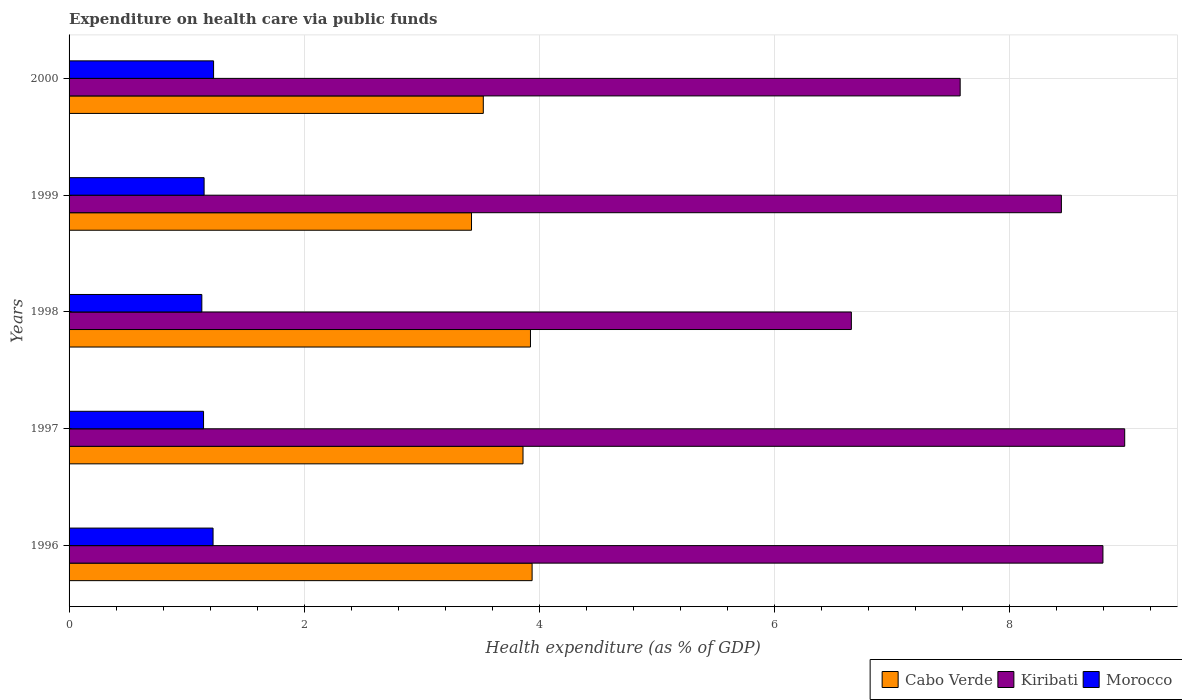How many different coloured bars are there?
Offer a very short reply. 3. Are the number of bars on each tick of the Y-axis equal?
Provide a short and direct response. Yes. How many bars are there on the 5th tick from the top?
Ensure brevity in your answer.  3. In how many cases, is the number of bars for a given year not equal to the number of legend labels?
Your answer should be very brief. 0. What is the expenditure made on health care in Kiribati in 1996?
Give a very brief answer. 8.8. Across all years, what is the maximum expenditure made on health care in Kiribati?
Your answer should be compact. 8.98. Across all years, what is the minimum expenditure made on health care in Morocco?
Provide a short and direct response. 1.13. In which year was the expenditure made on health care in Kiribati maximum?
Your answer should be very brief. 1997. What is the total expenditure made on health care in Morocco in the graph?
Ensure brevity in your answer.  5.88. What is the difference between the expenditure made on health care in Cabo Verde in 1998 and that in 2000?
Make the answer very short. 0.4. What is the difference between the expenditure made on health care in Cabo Verde in 1996 and the expenditure made on health care in Kiribati in 1998?
Offer a terse response. -2.72. What is the average expenditure made on health care in Cabo Verde per year?
Provide a short and direct response. 3.74. In the year 1996, what is the difference between the expenditure made on health care in Kiribati and expenditure made on health care in Morocco?
Make the answer very short. 7.57. In how many years, is the expenditure made on health care in Cabo Verde greater than 7.2 %?
Keep it short and to the point. 0. What is the ratio of the expenditure made on health care in Morocco in 1997 to that in 1998?
Give a very brief answer. 1.01. Is the expenditure made on health care in Cabo Verde in 1996 less than that in 2000?
Provide a succinct answer. No. Is the difference between the expenditure made on health care in Kiribati in 1996 and 2000 greater than the difference between the expenditure made on health care in Morocco in 1996 and 2000?
Your answer should be very brief. Yes. What is the difference between the highest and the second highest expenditure made on health care in Morocco?
Ensure brevity in your answer.  0. What is the difference between the highest and the lowest expenditure made on health care in Kiribati?
Provide a succinct answer. 2.33. In how many years, is the expenditure made on health care in Morocco greater than the average expenditure made on health care in Morocco taken over all years?
Ensure brevity in your answer.  2. What does the 2nd bar from the top in 2000 represents?
Offer a very short reply. Kiribati. What does the 3rd bar from the bottom in 2000 represents?
Keep it short and to the point. Morocco. Is it the case that in every year, the sum of the expenditure made on health care in Kiribati and expenditure made on health care in Morocco is greater than the expenditure made on health care in Cabo Verde?
Your answer should be very brief. Yes. How many years are there in the graph?
Make the answer very short. 5. What is the difference between two consecutive major ticks on the X-axis?
Your answer should be very brief. 2. Does the graph contain grids?
Your response must be concise. Yes. How many legend labels are there?
Make the answer very short. 3. What is the title of the graph?
Give a very brief answer. Expenditure on health care via public funds. Does "Palau" appear as one of the legend labels in the graph?
Keep it short and to the point. No. What is the label or title of the X-axis?
Your answer should be compact. Health expenditure (as % of GDP). What is the Health expenditure (as % of GDP) of Cabo Verde in 1996?
Your answer should be very brief. 3.94. What is the Health expenditure (as % of GDP) in Kiribati in 1996?
Offer a terse response. 8.8. What is the Health expenditure (as % of GDP) of Morocco in 1996?
Provide a succinct answer. 1.23. What is the Health expenditure (as % of GDP) of Cabo Verde in 1997?
Your answer should be very brief. 3.86. What is the Health expenditure (as % of GDP) in Kiribati in 1997?
Make the answer very short. 8.98. What is the Health expenditure (as % of GDP) of Morocco in 1997?
Provide a short and direct response. 1.14. What is the Health expenditure (as % of GDP) of Cabo Verde in 1998?
Your answer should be very brief. 3.93. What is the Health expenditure (as % of GDP) of Kiribati in 1998?
Ensure brevity in your answer.  6.66. What is the Health expenditure (as % of GDP) of Morocco in 1998?
Make the answer very short. 1.13. What is the Health expenditure (as % of GDP) in Cabo Verde in 1999?
Offer a terse response. 3.42. What is the Health expenditure (as % of GDP) in Kiribati in 1999?
Ensure brevity in your answer.  8.44. What is the Health expenditure (as % of GDP) in Morocco in 1999?
Ensure brevity in your answer.  1.15. What is the Health expenditure (as % of GDP) of Cabo Verde in 2000?
Keep it short and to the point. 3.52. What is the Health expenditure (as % of GDP) in Kiribati in 2000?
Your answer should be compact. 7.58. What is the Health expenditure (as % of GDP) in Morocco in 2000?
Offer a very short reply. 1.23. Across all years, what is the maximum Health expenditure (as % of GDP) of Cabo Verde?
Provide a short and direct response. 3.94. Across all years, what is the maximum Health expenditure (as % of GDP) in Kiribati?
Provide a succinct answer. 8.98. Across all years, what is the maximum Health expenditure (as % of GDP) of Morocco?
Provide a succinct answer. 1.23. Across all years, what is the minimum Health expenditure (as % of GDP) in Cabo Verde?
Offer a very short reply. 3.42. Across all years, what is the minimum Health expenditure (as % of GDP) of Kiribati?
Your answer should be compact. 6.66. Across all years, what is the minimum Health expenditure (as % of GDP) of Morocco?
Provide a succinct answer. 1.13. What is the total Health expenditure (as % of GDP) of Cabo Verde in the graph?
Provide a short and direct response. 18.68. What is the total Health expenditure (as % of GDP) in Kiribati in the graph?
Ensure brevity in your answer.  40.46. What is the total Health expenditure (as % of GDP) of Morocco in the graph?
Your answer should be very brief. 5.88. What is the difference between the Health expenditure (as % of GDP) of Cabo Verde in 1996 and that in 1997?
Your answer should be very brief. 0.08. What is the difference between the Health expenditure (as % of GDP) of Kiribati in 1996 and that in 1997?
Provide a short and direct response. -0.19. What is the difference between the Health expenditure (as % of GDP) of Morocco in 1996 and that in 1997?
Your answer should be very brief. 0.08. What is the difference between the Health expenditure (as % of GDP) in Cabo Verde in 1996 and that in 1998?
Keep it short and to the point. 0.01. What is the difference between the Health expenditure (as % of GDP) of Kiribati in 1996 and that in 1998?
Provide a succinct answer. 2.14. What is the difference between the Health expenditure (as % of GDP) of Morocco in 1996 and that in 1998?
Ensure brevity in your answer.  0.1. What is the difference between the Health expenditure (as % of GDP) of Cabo Verde in 1996 and that in 1999?
Provide a succinct answer. 0.52. What is the difference between the Health expenditure (as % of GDP) in Kiribati in 1996 and that in 1999?
Give a very brief answer. 0.35. What is the difference between the Health expenditure (as % of GDP) in Morocco in 1996 and that in 1999?
Make the answer very short. 0.08. What is the difference between the Health expenditure (as % of GDP) in Cabo Verde in 1996 and that in 2000?
Provide a short and direct response. 0.42. What is the difference between the Health expenditure (as % of GDP) in Kiribati in 1996 and that in 2000?
Give a very brief answer. 1.21. What is the difference between the Health expenditure (as % of GDP) in Morocco in 1996 and that in 2000?
Keep it short and to the point. -0. What is the difference between the Health expenditure (as % of GDP) of Cabo Verde in 1997 and that in 1998?
Provide a short and direct response. -0.06. What is the difference between the Health expenditure (as % of GDP) of Kiribati in 1997 and that in 1998?
Keep it short and to the point. 2.33. What is the difference between the Health expenditure (as % of GDP) of Morocco in 1997 and that in 1998?
Offer a very short reply. 0.01. What is the difference between the Health expenditure (as % of GDP) in Cabo Verde in 1997 and that in 1999?
Provide a succinct answer. 0.44. What is the difference between the Health expenditure (as % of GDP) of Kiribati in 1997 and that in 1999?
Ensure brevity in your answer.  0.54. What is the difference between the Health expenditure (as % of GDP) in Morocco in 1997 and that in 1999?
Provide a succinct answer. -0. What is the difference between the Health expenditure (as % of GDP) in Cabo Verde in 1997 and that in 2000?
Your response must be concise. 0.34. What is the difference between the Health expenditure (as % of GDP) in Kiribati in 1997 and that in 2000?
Give a very brief answer. 1.4. What is the difference between the Health expenditure (as % of GDP) in Morocco in 1997 and that in 2000?
Ensure brevity in your answer.  -0.09. What is the difference between the Health expenditure (as % of GDP) of Cabo Verde in 1998 and that in 1999?
Offer a very short reply. 0.5. What is the difference between the Health expenditure (as % of GDP) of Kiribati in 1998 and that in 1999?
Keep it short and to the point. -1.79. What is the difference between the Health expenditure (as % of GDP) in Morocco in 1998 and that in 1999?
Make the answer very short. -0.02. What is the difference between the Health expenditure (as % of GDP) in Cabo Verde in 1998 and that in 2000?
Ensure brevity in your answer.  0.4. What is the difference between the Health expenditure (as % of GDP) in Kiribati in 1998 and that in 2000?
Keep it short and to the point. -0.93. What is the difference between the Health expenditure (as % of GDP) in Morocco in 1998 and that in 2000?
Offer a very short reply. -0.1. What is the difference between the Health expenditure (as % of GDP) of Cabo Verde in 1999 and that in 2000?
Keep it short and to the point. -0.1. What is the difference between the Health expenditure (as % of GDP) of Kiribati in 1999 and that in 2000?
Your answer should be very brief. 0.86. What is the difference between the Health expenditure (as % of GDP) in Morocco in 1999 and that in 2000?
Ensure brevity in your answer.  -0.08. What is the difference between the Health expenditure (as % of GDP) of Cabo Verde in 1996 and the Health expenditure (as % of GDP) of Kiribati in 1997?
Offer a very short reply. -5.04. What is the difference between the Health expenditure (as % of GDP) in Cabo Verde in 1996 and the Health expenditure (as % of GDP) in Morocco in 1997?
Make the answer very short. 2.8. What is the difference between the Health expenditure (as % of GDP) of Kiribati in 1996 and the Health expenditure (as % of GDP) of Morocco in 1997?
Provide a succinct answer. 7.65. What is the difference between the Health expenditure (as % of GDP) in Cabo Verde in 1996 and the Health expenditure (as % of GDP) in Kiribati in 1998?
Your response must be concise. -2.72. What is the difference between the Health expenditure (as % of GDP) of Cabo Verde in 1996 and the Health expenditure (as % of GDP) of Morocco in 1998?
Provide a succinct answer. 2.81. What is the difference between the Health expenditure (as % of GDP) of Kiribati in 1996 and the Health expenditure (as % of GDP) of Morocco in 1998?
Provide a succinct answer. 7.67. What is the difference between the Health expenditure (as % of GDP) in Cabo Verde in 1996 and the Health expenditure (as % of GDP) in Kiribati in 1999?
Your answer should be compact. -4.5. What is the difference between the Health expenditure (as % of GDP) in Cabo Verde in 1996 and the Health expenditure (as % of GDP) in Morocco in 1999?
Offer a terse response. 2.79. What is the difference between the Health expenditure (as % of GDP) of Kiribati in 1996 and the Health expenditure (as % of GDP) of Morocco in 1999?
Your answer should be compact. 7.65. What is the difference between the Health expenditure (as % of GDP) in Cabo Verde in 1996 and the Health expenditure (as % of GDP) in Kiribati in 2000?
Offer a very short reply. -3.64. What is the difference between the Health expenditure (as % of GDP) in Cabo Verde in 1996 and the Health expenditure (as % of GDP) in Morocco in 2000?
Offer a very short reply. 2.71. What is the difference between the Health expenditure (as % of GDP) in Kiribati in 1996 and the Health expenditure (as % of GDP) in Morocco in 2000?
Ensure brevity in your answer.  7.57. What is the difference between the Health expenditure (as % of GDP) of Cabo Verde in 1997 and the Health expenditure (as % of GDP) of Kiribati in 1998?
Provide a succinct answer. -2.79. What is the difference between the Health expenditure (as % of GDP) of Cabo Verde in 1997 and the Health expenditure (as % of GDP) of Morocco in 1998?
Offer a terse response. 2.73. What is the difference between the Health expenditure (as % of GDP) of Kiribati in 1997 and the Health expenditure (as % of GDP) of Morocco in 1998?
Keep it short and to the point. 7.85. What is the difference between the Health expenditure (as % of GDP) of Cabo Verde in 1997 and the Health expenditure (as % of GDP) of Kiribati in 1999?
Make the answer very short. -4.58. What is the difference between the Health expenditure (as % of GDP) of Cabo Verde in 1997 and the Health expenditure (as % of GDP) of Morocco in 1999?
Make the answer very short. 2.71. What is the difference between the Health expenditure (as % of GDP) of Kiribati in 1997 and the Health expenditure (as % of GDP) of Morocco in 1999?
Provide a short and direct response. 7.83. What is the difference between the Health expenditure (as % of GDP) of Cabo Verde in 1997 and the Health expenditure (as % of GDP) of Kiribati in 2000?
Your response must be concise. -3.72. What is the difference between the Health expenditure (as % of GDP) of Cabo Verde in 1997 and the Health expenditure (as % of GDP) of Morocco in 2000?
Your response must be concise. 2.63. What is the difference between the Health expenditure (as % of GDP) in Kiribati in 1997 and the Health expenditure (as % of GDP) in Morocco in 2000?
Keep it short and to the point. 7.75. What is the difference between the Health expenditure (as % of GDP) of Cabo Verde in 1998 and the Health expenditure (as % of GDP) of Kiribati in 1999?
Make the answer very short. -4.52. What is the difference between the Health expenditure (as % of GDP) in Cabo Verde in 1998 and the Health expenditure (as % of GDP) in Morocco in 1999?
Your answer should be very brief. 2.78. What is the difference between the Health expenditure (as % of GDP) in Kiribati in 1998 and the Health expenditure (as % of GDP) in Morocco in 1999?
Ensure brevity in your answer.  5.51. What is the difference between the Health expenditure (as % of GDP) of Cabo Verde in 1998 and the Health expenditure (as % of GDP) of Kiribati in 2000?
Provide a succinct answer. -3.66. What is the difference between the Health expenditure (as % of GDP) in Cabo Verde in 1998 and the Health expenditure (as % of GDP) in Morocco in 2000?
Offer a terse response. 2.7. What is the difference between the Health expenditure (as % of GDP) of Kiribati in 1998 and the Health expenditure (as % of GDP) of Morocco in 2000?
Your response must be concise. 5.43. What is the difference between the Health expenditure (as % of GDP) in Cabo Verde in 1999 and the Health expenditure (as % of GDP) in Kiribati in 2000?
Ensure brevity in your answer.  -4.16. What is the difference between the Health expenditure (as % of GDP) in Cabo Verde in 1999 and the Health expenditure (as % of GDP) in Morocco in 2000?
Ensure brevity in your answer.  2.19. What is the difference between the Health expenditure (as % of GDP) in Kiribati in 1999 and the Health expenditure (as % of GDP) in Morocco in 2000?
Your answer should be very brief. 7.21. What is the average Health expenditure (as % of GDP) in Cabo Verde per year?
Give a very brief answer. 3.74. What is the average Health expenditure (as % of GDP) in Kiribati per year?
Keep it short and to the point. 8.09. What is the average Health expenditure (as % of GDP) in Morocco per year?
Keep it short and to the point. 1.18. In the year 1996, what is the difference between the Health expenditure (as % of GDP) of Cabo Verde and Health expenditure (as % of GDP) of Kiribati?
Your answer should be compact. -4.86. In the year 1996, what is the difference between the Health expenditure (as % of GDP) in Cabo Verde and Health expenditure (as % of GDP) in Morocco?
Make the answer very short. 2.71. In the year 1996, what is the difference between the Health expenditure (as % of GDP) in Kiribati and Health expenditure (as % of GDP) in Morocco?
Your answer should be very brief. 7.57. In the year 1997, what is the difference between the Health expenditure (as % of GDP) of Cabo Verde and Health expenditure (as % of GDP) of Kiribati?
Offer a terse response. -5.12. In the year 1997, what is the difference between the Health expenditure (as % of GDP) of Cabo Verde and Health expenditure (as % of GDP) of Morocco?
Give a very brief answer. 2.72. In the year 1997, what is the difference between the Health expenditure (as % of GDP) of Kiribati and Health expenditure (as % of GDP) of Morocco?
Keep it short and to the point. 7.84. In the year 1998, what is the difference between the Health expenditure (as % of GDP) in Cabo Verde and Health expenditure (as % of GDP) in Kiribati?
Provide a succinct answer. -2.73. In the year 1998, what is the difference between the Health expenditure (as % of GDP) in Cabo Verde and Health expenditure (as % of GDP) in Morocco?
Your answer should be very brief. 2.8. In the year 1998, what is the difference between the Health expenditure (as % of GDP) in Kiribati and Health expenditure (as % of GDP) in Morocco?
Provide a succinct answer. 5.53. In the year 1999, what is the difference between the Health expenditure (as % of GDP) in Cabo Verde and Health expenditure (as % of GDP) in Kiribati?
Ensure brevity in your answer.  -5.02. In the year 1999, what is the difference between the Health expenditure (as % of GDP) of Cabo Verde and Health expenditure (as % of GDP) of Morocco?
Offer a terse response. 2.28. In the year 1999, what is the difference between the Health expenditure (as % of GDP) of Kiribati and Health expenditure (as % of GDP) of Morocco?
Make the answer very short. 7.3. In the year 2000, what is the difference between the Health expenditure (as % of GDP) of Cabo Verde and Health expenditure (as % of GDP) of Kiribati?
Your answer should be very brief. -4.06. In the year 2000, what is the difference between the Health expenditure (as % of GDP) of Cabo Verde and Health expenditure (as % of GDP) of Morocco?
Your answer should be very brief. 2.3. In the year 2000, what is the difference between the Health expenditure (as % of GDP) of Kiribati and Health expenditure (as % of GDP) of Morocco?
Ensure brevity in your answer.  6.35. What is the ratio of the Health expenditure (as % of GDP) of Kiribati in 1996 to that in 1997?
Offer a very short reply. 0.98. What is the ratio of the Health expenditure (as % of GDP) of Morocco in 1996 to that in 1997?
Your response must be concise. 1.07. What is the ratio of the Health expenditure (as % of GDP) in Kiribati in 1996 to that in 1998?
Your response must be concise. 1.32. What is the ratio of the Health expenditure (as % of GDP) of Morocco in 1996 to that in 1998?
Keep it short and to the point. 1.08. What is the ratio of the Health expenditure (as % of GDP) in Cabo Verde in 1996 to that in 1999?
Your response must be concise. 1.15. What is the ratio of the Health expenditure (as % of GDP) in Kiribati in 1996 to that in 1999?
Offer a very short reply. 1.04. What is the ratio of the Health expenditure (as % of GDP) of Morocco in 1996 to that in 1999?
Offer a terse response. 1.07. What is the ratio of the Health expenditure (as % of GDP) in Cabo Verde in 1996 to that in 2000?
Give a very brief answer. 1.12. What is the ratio of the Health expenditure (as % of GDP) in Kiribati in 1996 to that in 2000?
Your answer should be very brief. 1.16. What is the ratio of the Health expenditure (as % of GDP) of Morocco in 1996 to that in 2000?
Provide a short and direct response. 1. What is the ratio of the Health expenditure (as % of GDP) of Cabo Verde in 1997 to that in 1998?
Offer a terse response. 0.98. What is the ratio of the Health expenditure (as % of GDP) of Kiribati in 1997 to that in 1998?
Give a very brief answer. 1.35. What is the ratio of the Health expenditure (as % of GDP) in Morocco in 1997 to that in 1998?
Provide a short and direct response. 1.01. What is the ratio of the Health expenditure (as % of GDP) in Cabo Verde in 1997 to that in 1999?
Provide a succinct answer. 1.13. What is the ratio of the Health expenditure (as % of GDP) of Kiribati in 1997 to that in 1999?
Your answer should be very brief. 1.06. What is the ratio of the Health expenditure (as % of GDP) in Cabo Verde in 1997 to that in 2000?
Your answer should be very brief. 1.1. What is the ratio of the Health expenditure (as % of GDP) of Kiribati in 1997 to that in 2000?
Ensure brevity in your answer.  1.18. What is the ratio of the Health expenditure (as % of GDP) in Morocco in 1997 to that in 2000?
Your answer should be very brief. 0.93. What is the ratio of the Health expenditure (as % of GDP) of Cabo Verde in 1998 to that in 1999?
Keep it short and to the point. 1.15. What is the ratio of the Health expenditure (as % of GDP) of Kiribati in 1998 to that in 1999?
Keep it short and to the point. 0.79. What is the ratio of the Health expenditure (as % of GDP) of Morocco in 1998 to that in 1999?
Your answer should be compact. 0.98. What is the ratio of the Health expenditure (as % of GDP) in Cabo Verde in 1998 to that in 2000?
Keep it short and to the point. 1.11. What is the ratio of the Health expenditure (as % of GDP) of Kiribati in 1998 to that in 2000?
Your answer should be compact. 0.88. What is the ratio of the Health expenditure (as % of GDP) in Morocco in 1998 to that in 2000?
Your response must be concise. 0.92. What is the ratio of the Health expenditure (as % of GDP) of Cabo Verde in 1999 to that in 2000?
Your response must be concise. 0.97. What is the ratio of the Health expenditure (as % of GDP) in Kiribati in 1999 to that in 2000?
Offer a terse response. 1.11. What is the ratio of the Health expenditure (as % of GDP) in Morocco in 1999 to that in 2000?
Keep it short and to the point. 0.93. What is the difference between the highest and the second highest Health expenditure (as % of GDP) of Cabo Verde?
Your answer should be very brief. 0.01. What is the difference between the highest and the second highest Health expenditure (as % of GDP) of Kiribati?
Keep it short and to the point. 0.19. What is the difference between the highest and the second highest Health expenditure (as % of GDP) of Morocco?
Provide a succinct answer. 0. What is the difference between the highest and the lowest Health expenditure (as % of GDP) in Cabo Verde?
Offer a very short reply. 0.52. What is the difference between the highest and the lowest Health expenditure (as % of GDP) in Kiribati?
Ensure brevity in your answer.  2.33. What is the difference between the highest and the lowest Health expenditure (as % of GDP) of Morocco?
Ensure brevity in your answer.  0.1. 